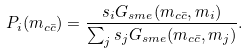<formula> <loc_0><loc_0><loc_500><loc_500>P _ { i } ( m _ { c \bar { c } } ) = \frac { s _ { i } G _ { s m e } ( m _ { c \bar { c } } , m _ { i } ) } { \sum _ { j } s _ { j } G _ { s m e } ( m _ { c \bar { c } } , m _ { j } ) } .</formula> 